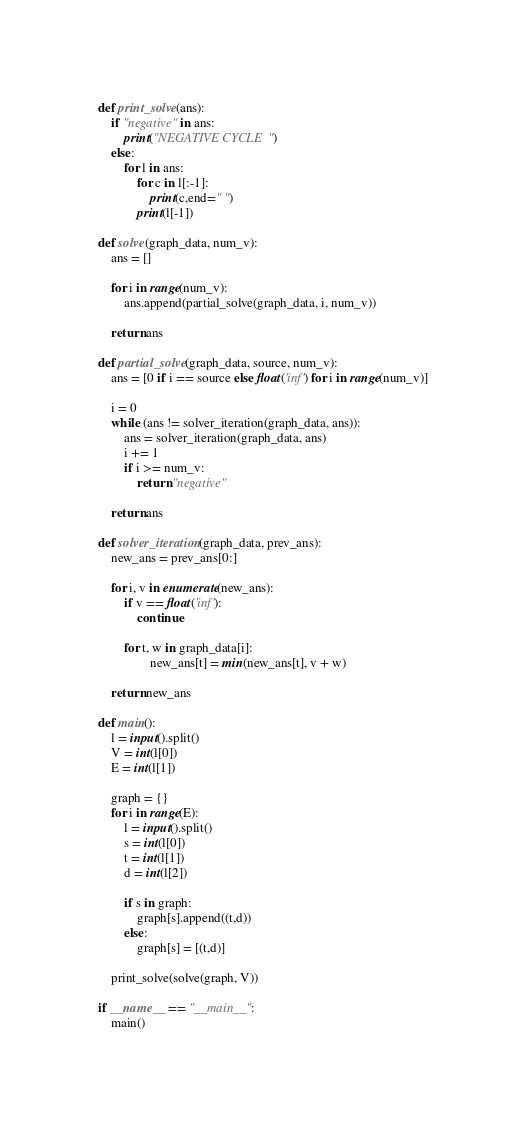<code> <loc_0><loc_0><loc_500><loc_500><_Python_>def print_solve(ans):
    if "negative" in ans:
        print("NEGATIVE CYCLE")
    else:
        for l in ans:
            for c in l[:-1]:
                print(c,end=" ")
            print(l[-1])

def solve(graph_data, num_v):
    ans = []

    for i in range(num_v):
        ans.append(partial_solve(graph_data, i, num_v))

    return ans

def partial_solve(graph_data, source, num_v):
    ans = [0 if i == source else float('inf') for i in range(num_v)]

    i = 0
    while (ans != solver_iteration(graph_data, ans)):
        ans = solver_iteration(graph_data, ans)
        i += 1
        if i >= num_v:
            return "negative"

    return ans

def solver_iteration(graph_data, prev_ans):
    new_ans = prev_ans[0:]

    for i, v in enumerate(new_ans):
        if v == float('inf'):
            continue

        for t, w in graph_data[i]:
                new_ans[t] = min(new_ans[t], v + w)

    return new_ans

def main():
    l = input().split()
    V = int(l[0])
    E = int(l[1])

    graph = {}
    for i in range(E):
        l = input().split()
        s = int(l[0])
        t = int(l[1])
        d = int(l[2])

        if s in graph:
            graph[s].append((t,d))
        else:
            graph[s] = [(t,d)]

    print_solve(solve(graph, V))

if __name__ == "__main__":
    main()</code> 